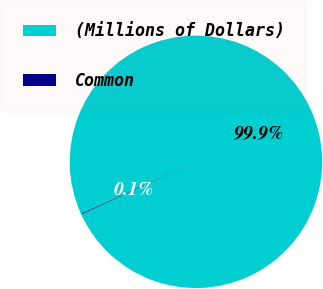Convert chart. <chart><loc_0><loc_0><loc_500><loc_500><pie_chart><fcel>(Millions of Dollars)<fcel>Common<nl><fcel>99.9%<fcel>0.1%<nl></chart> 